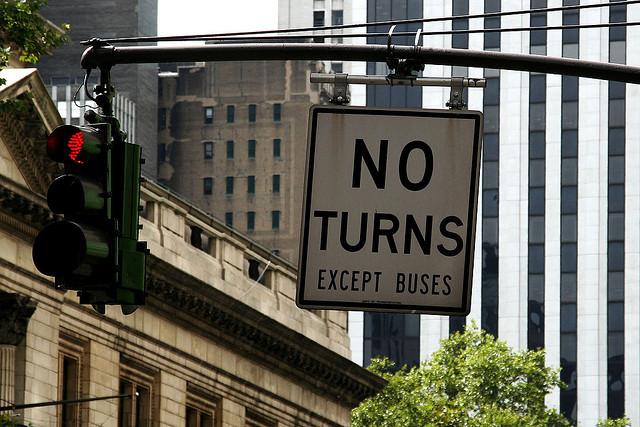Is this at an intersection?
Be succinct. Yes. Are trams excepted?
Quick response, please. No. What does the sign say?
Short answer required. No turns except buses. Can buses turn here?
Be succinct. Yes. 